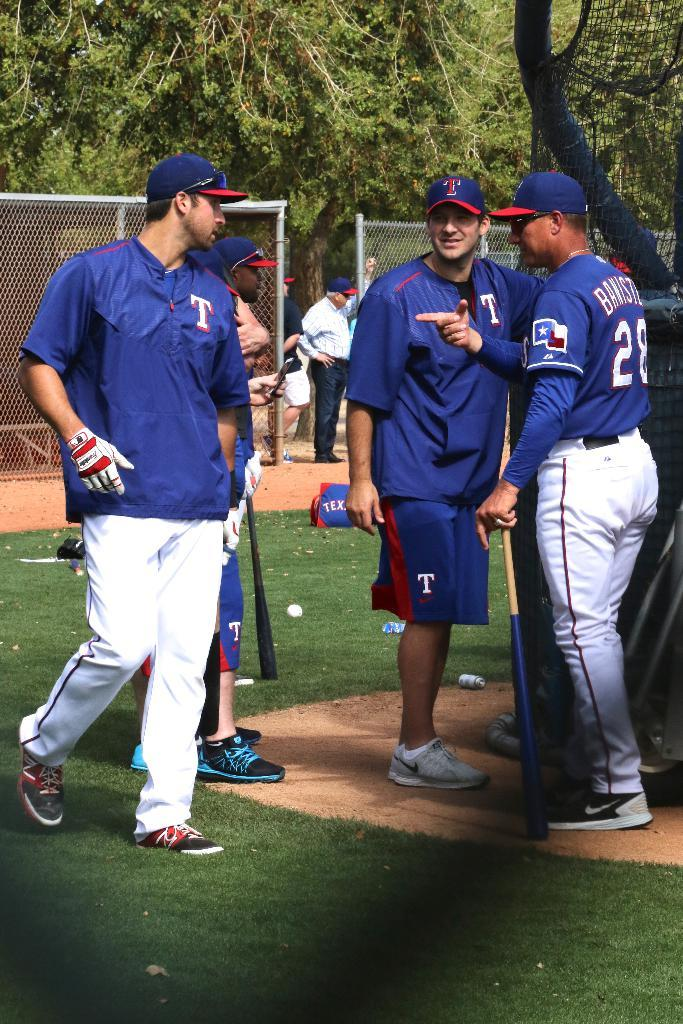<image>
Describe the image concisely. 3 baseball players wearing a blue uniform with a T on it. 